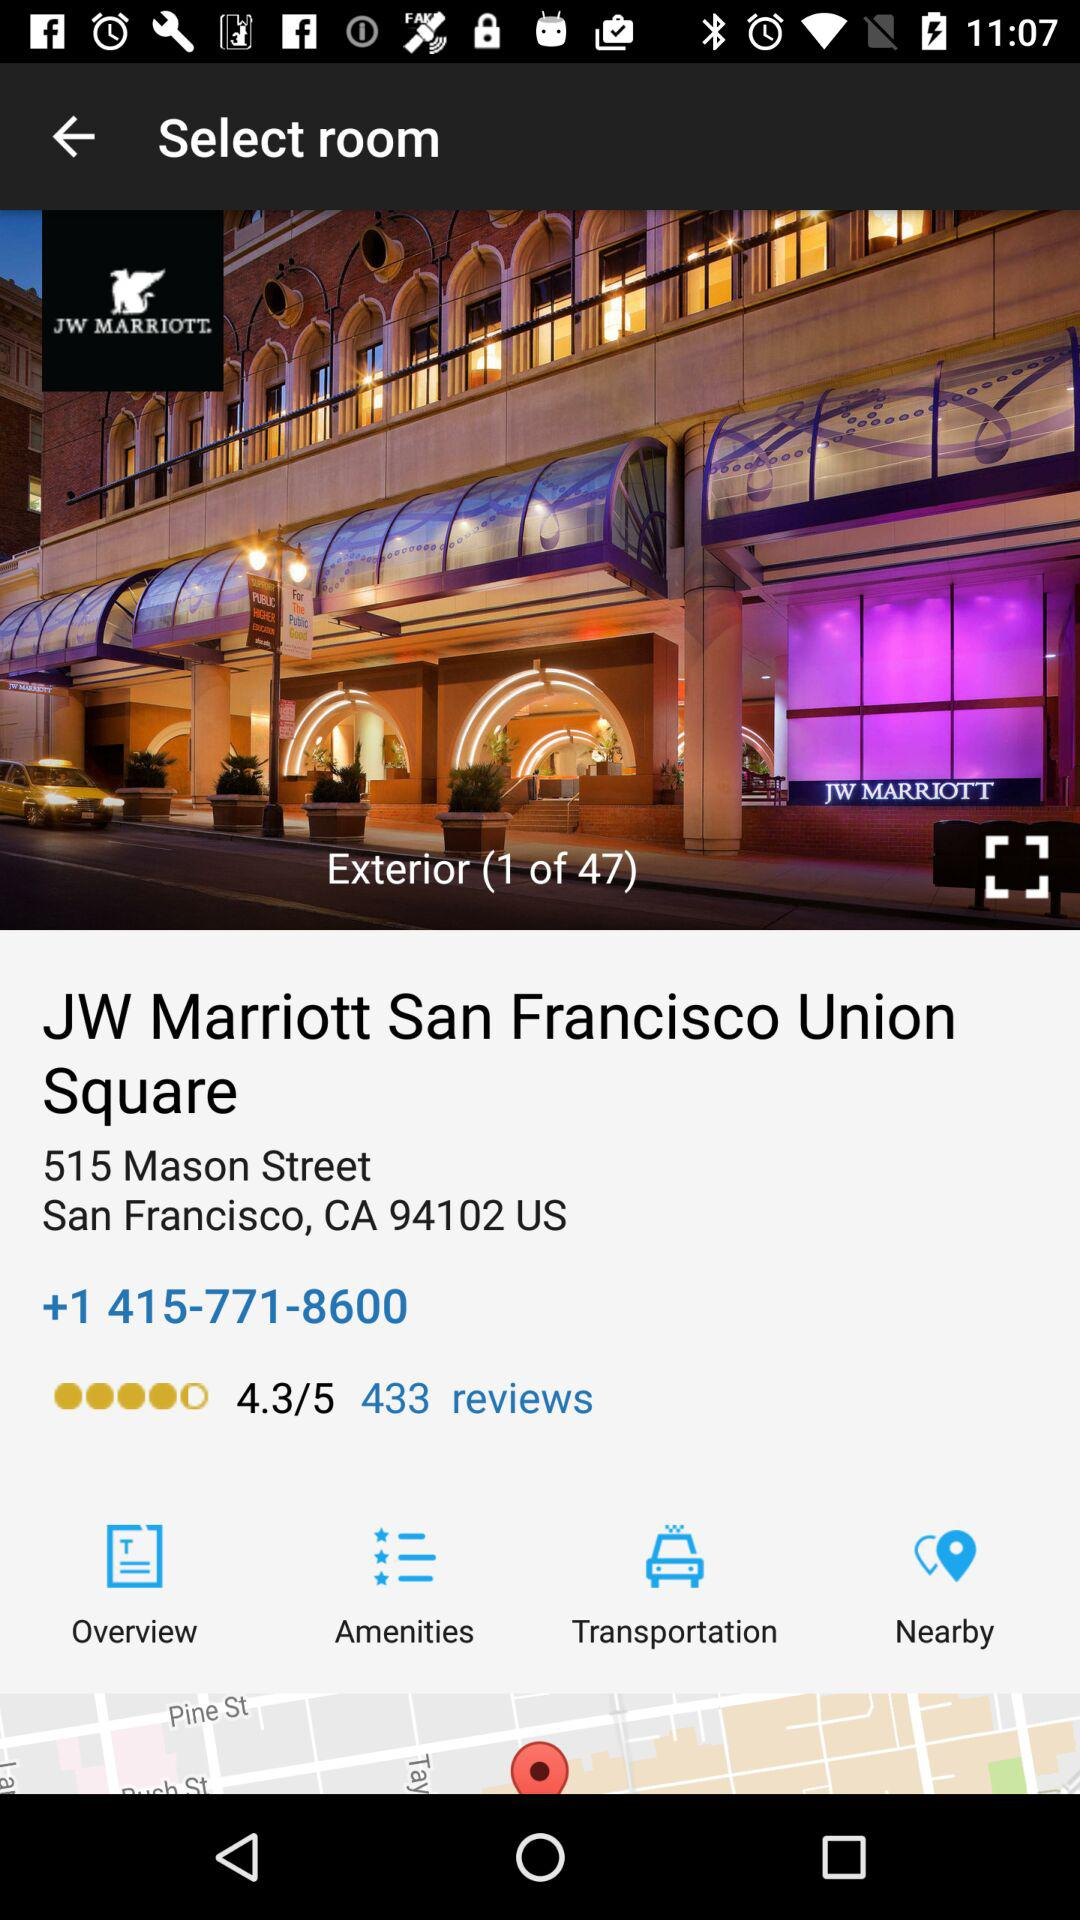How many reviews are there? There are 433 reviews. 